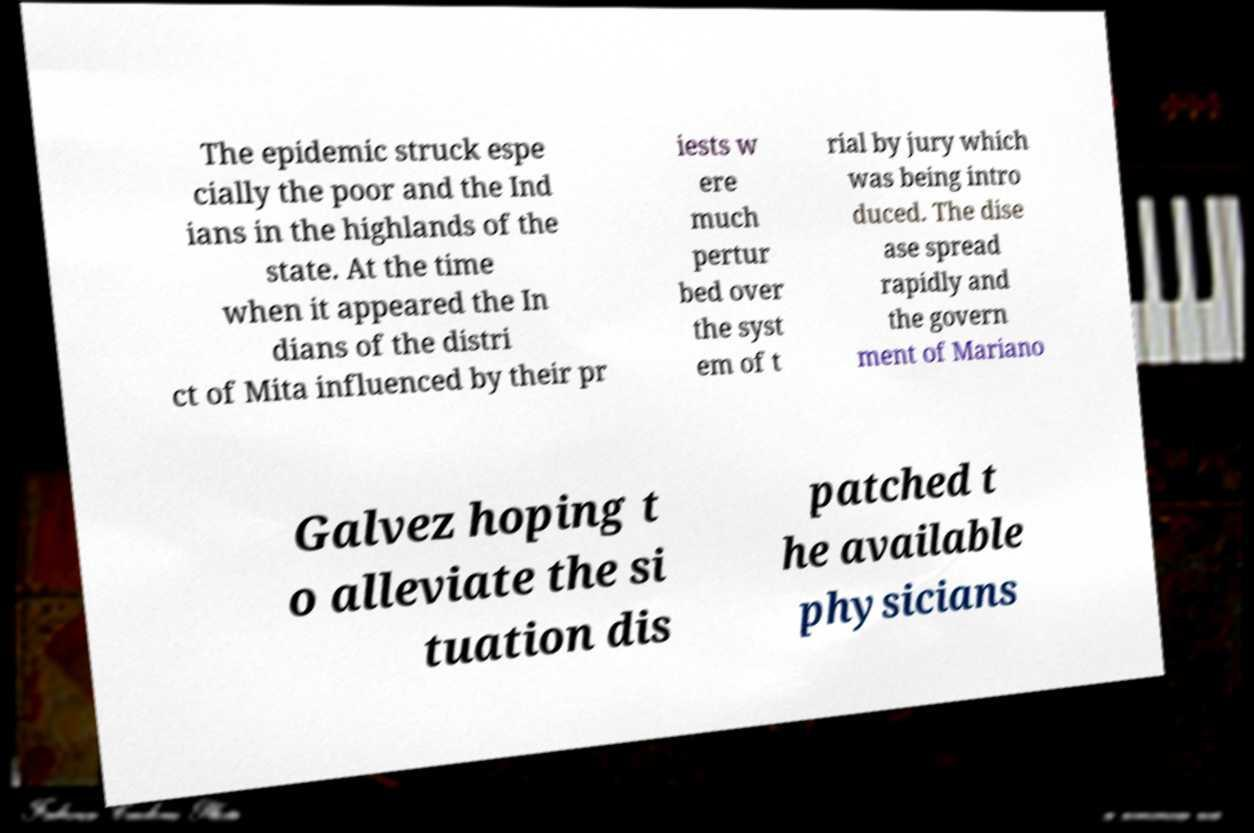Please read and relay the text visible in this image. What does it say? The epidemic struck espe cially the poor and the Ind ians in the highlands of the state. At the time when it appeared the In dians of the distri ct of Mita influenced by their pr iests w ere much pertur bed over the syst em of t rial by jury which was being intro duced. The dise ase spread rapidly and the govern ment of Mariano Galvez hoping t o alleviate the si tuation dis patched t he available physicians 